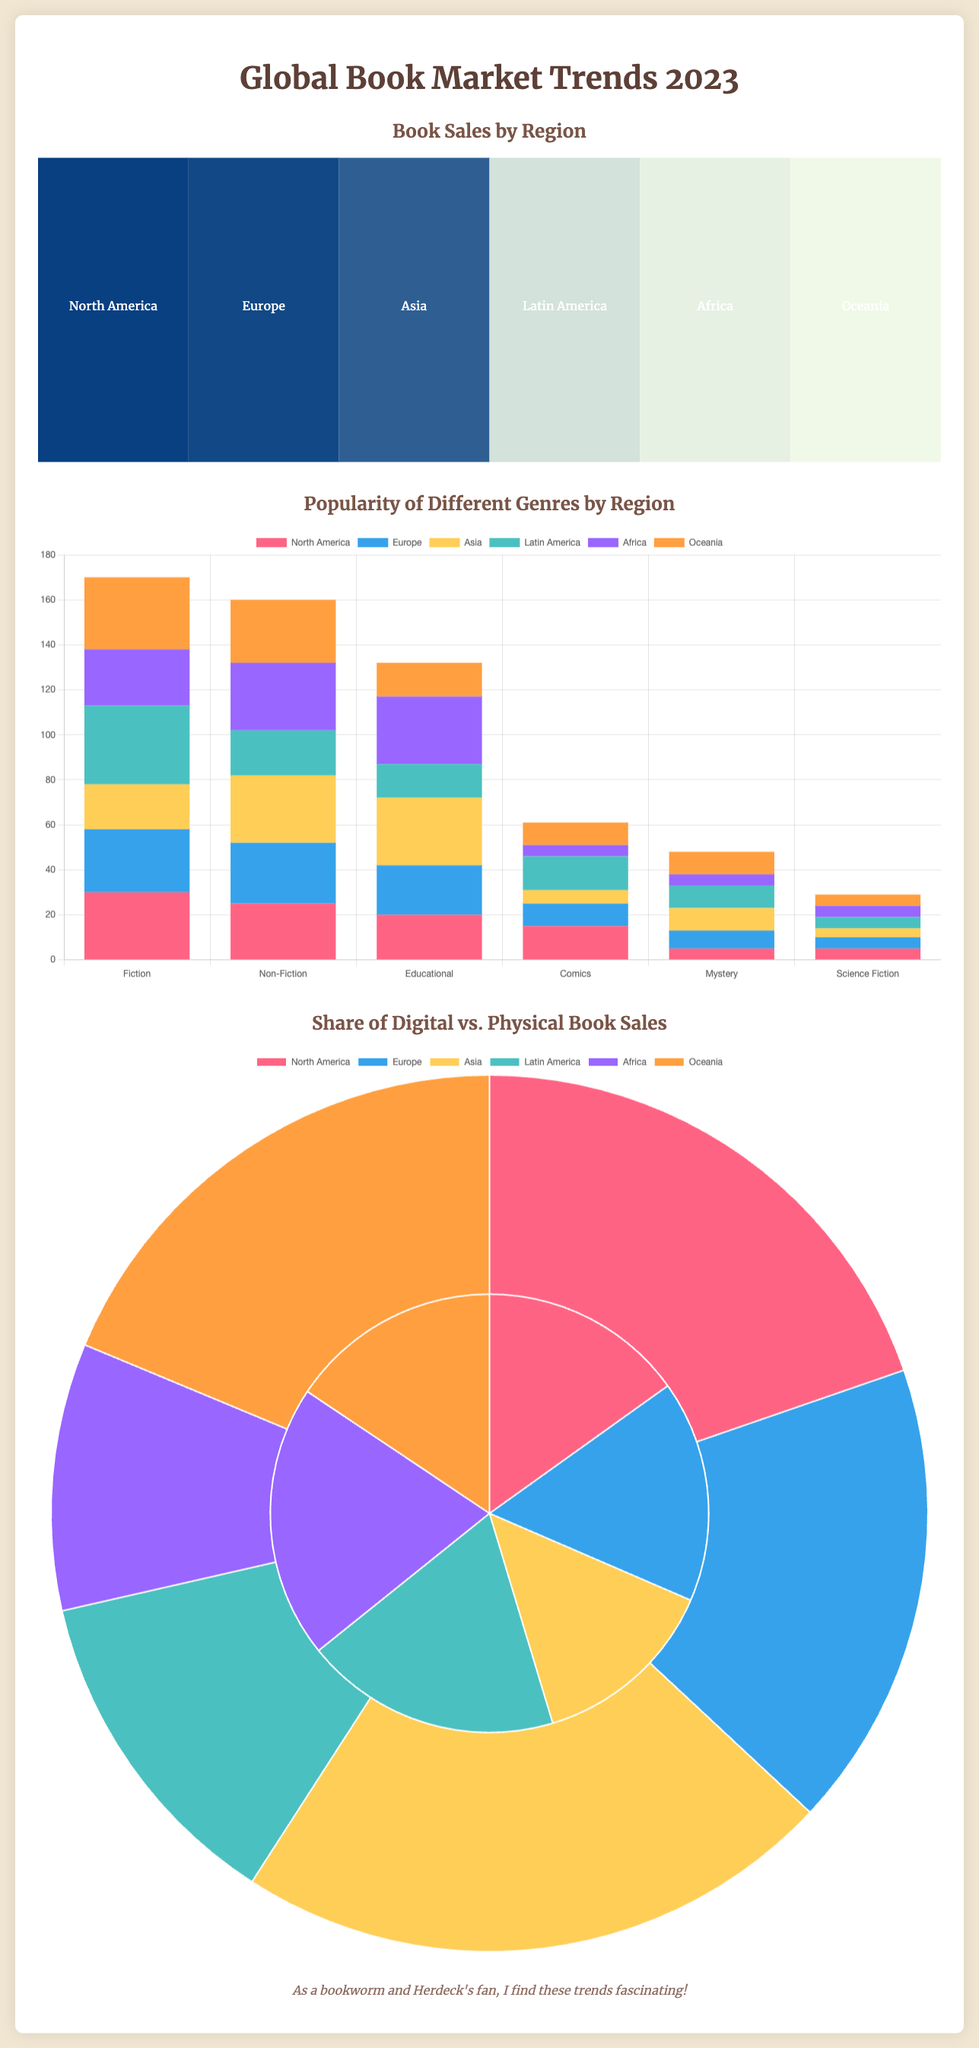What is the total book sales in North America? The total book sales in North America is $5,400,000,000, as shown in the heatmap.
Answer: $5,400,000,000 Which region has the lowest book sales? The region with the lowest book sales is Africa, with sales of $800,000,000 according to the heatmap.
Answer: Africa What is the most popular genre in Asia? In Asia, the most popular genre is Non-Fiction, as depicted in the bar chart.
Answer: Non-Fiction What percentage of book sales in Latin America are physical books? The percentage of physical book sales in Latin America is 75%, according to the pie chart.
Answer: 75% Which region has the highest percentage of digital book sales? The region with the highest percentage of digital book sales is Asia at 45%, as shown in the pie chart.
Answer: Asia What genre has the least popularity in Europe? The least popular genre in Europe is Comics, as represented in the bar chart.
Answer: Comics How many genres are compared in the bar chart? The bar chart compares a total of six genres in the document.
Answer: Six What color represents Fiction in the bar chart? Fiction is represented by the color pink in the bar chart.
Answer: Pink What is the total book sales figure for Africa? The total book sales figure for Africa stands at $800,000,000 according to the heatmap.
Answer: $800,000,000 